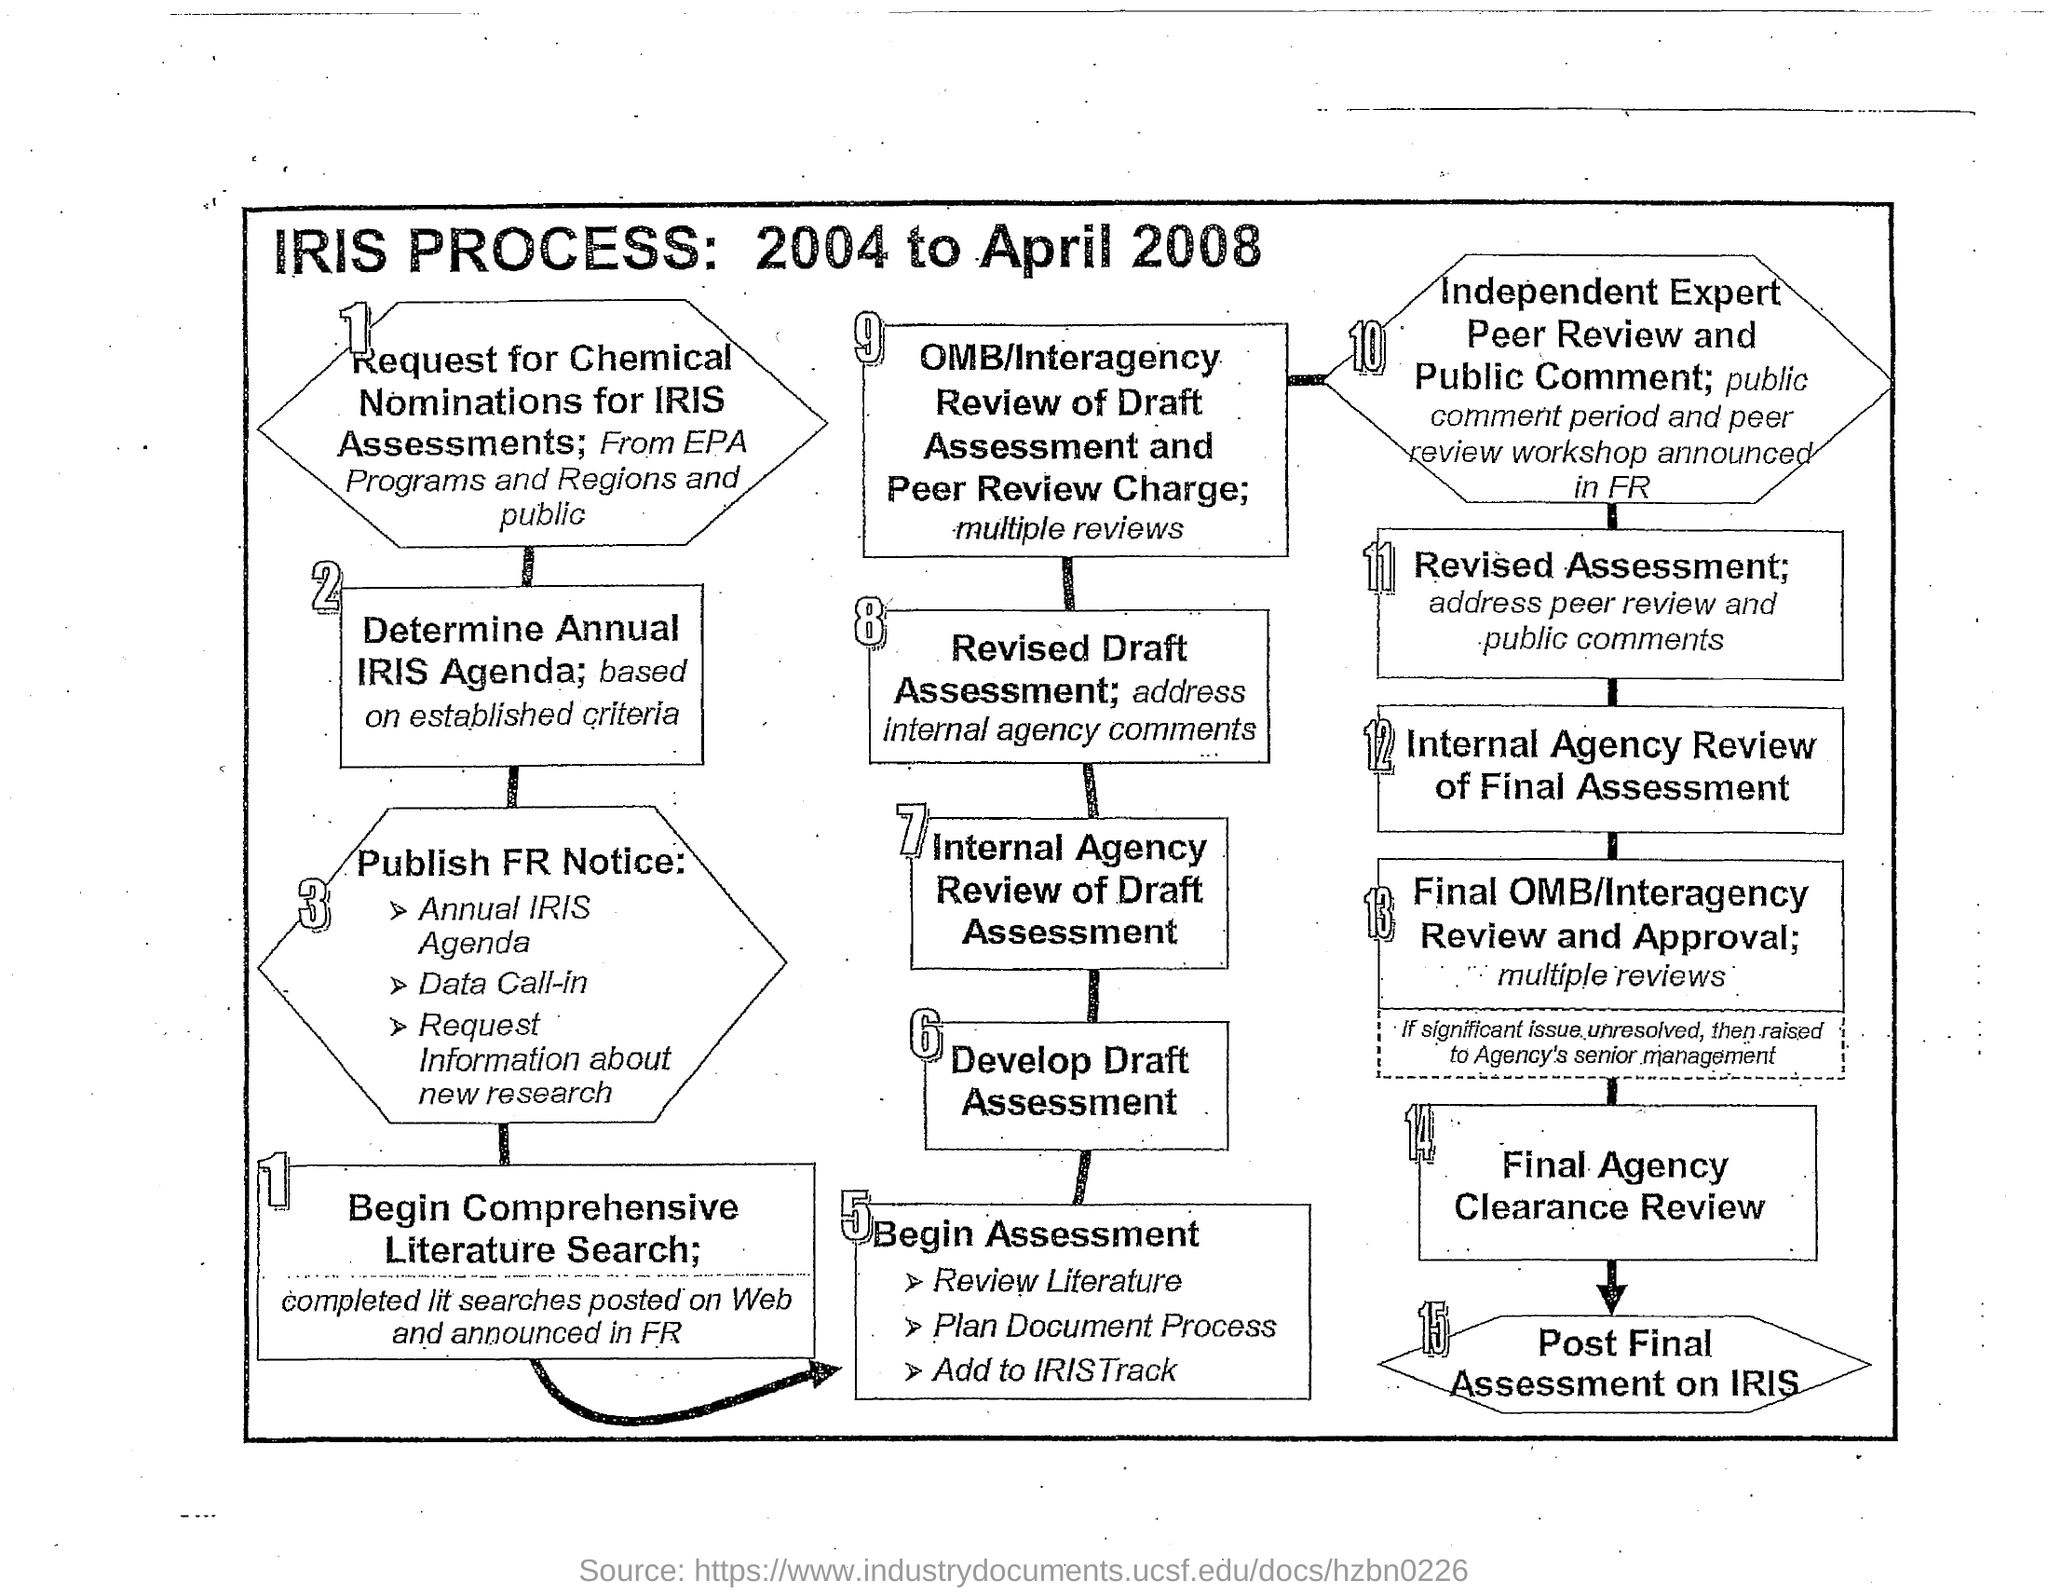Which process is given in the flowchart?
Make the answer very short. IRIS Process. 